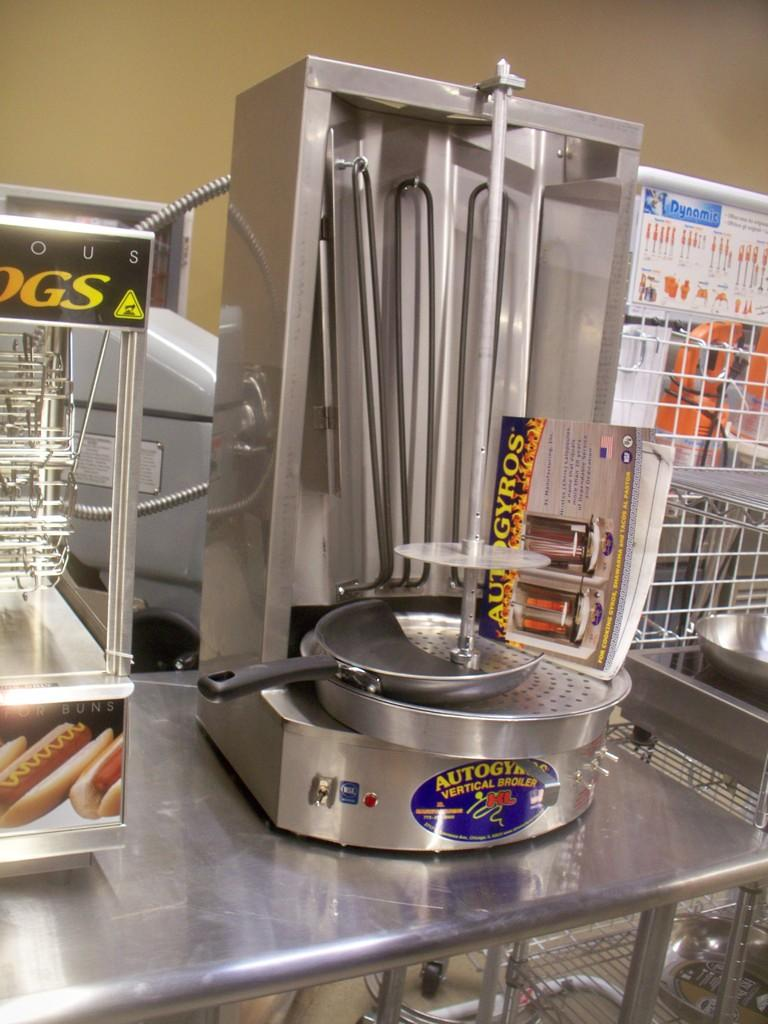<image>
Render a clear and concise summary of the photo. A hot dog cooker is next to a vertical hotdog broiler 